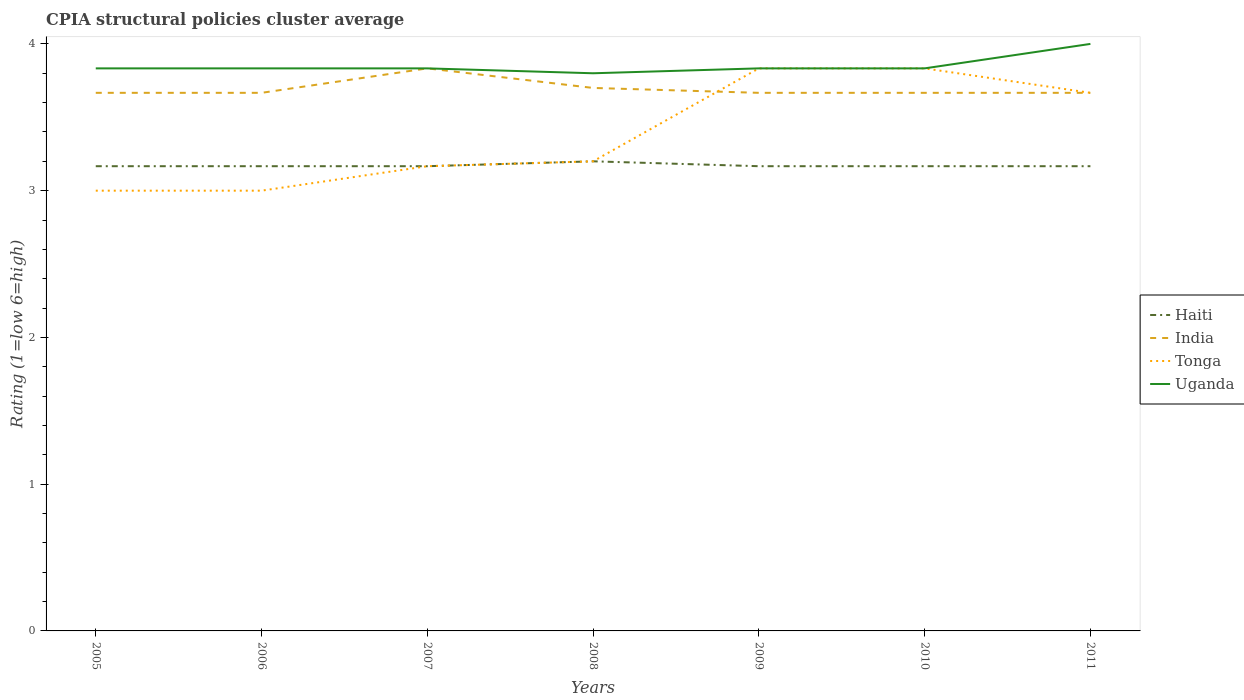Does the line corresponding to India intersect with the line corresponding to Uganda?
Your answer should be compact. Yes. What is the total CPIA rating in India in the graph?
Provide a short and direct response. 0.03. What is the difference between the highest and the second highest CPIA rating in India?
Your response must be concise. 0.17. What is the difference between the highest and the lowest CPIA rating in Haiti?
Your answer should be very brief. 1. Is the CPIA rating in Uganda strictly greater than the CPIA rating in India over the years?
Keep it short and to the point. No. What is the difference between two consecutive major ticks on the Y-axis?
Offer a terse response. 1. Where does the legend appear in the graph?
Make the answer very short. Center right. How many legend labels are there?
Offer a terse response. 4. How are the legend labels stacked?
Provide a succinct answer. Vertical. What is the title of the graph?
Make the answer very short. CPIA structural policies cluster average. Does "Russian Federation" appear as one of the legend labels in the graph?
Provide a succinct answer. No. What is the label or title of the X-axis?
Offer a very short reply. Years. What is the Rating (1=low 6=high) in Haiti in 2005?
Your answer should be compact. 3.17. What is the Rating (1=low 6=high) of India in 2005?
Your answer should be very brief. 3.67. What is the Rating (1=low 6=high) of Uganda in 2005?
Your answer should be very brief. 3.83. What is the Rating (1=low 6=high) of Haiti in 2006?
Give a very brief answer. 3.17. What is the Rating (1=low 6=high) of India in 2006?
Offer a very short reply. 3.67. What is the Rating (1=low 6=high) of Uganda in 2006?
Ensure brevity in your answer.  3.83. What is the Rating (1=low 6=high) in Haiti in 2007?
Provide a succinct answer. 3.17. What is the Rating (1=low 6=high) in India in 2007?
Offer a very short reply. 3.83. What is the Rating (1=low 6=high) of Tonga in 2007?
Make the answer very short. 3.17. What is the Rating (1=low 6=high) of Uganda in 2007?
Your answer should be compact. 3.83. What is the Rating (1=low 6=high) in Haiti in 2008?
Offer a terse response. 3.2. What is the Rating (1=low 6=high) of Tonga in 2008?
Offer a very short reply. 3.2. What is the Rating (1=low 6=high) in Haiti in 2009?
Your response must be concise. 3.17. What is the Rating (1=low 6=high) of India in 2009?
Your answer should be compact. 3.67. What is the Rating (1=low 6=high) in Tonga in 2009?
Ensure brevity in your answer.  3.83. What is the Rating (1=low 6=high) of Uganda in 2009?
Your answer should be very brief. 3.83. What is the Rating (1=low 6=high) of Haiti in 2010?
Offer a terse response. 3.17. What is the Rating (1=low 6=high) of India in 2010?
Your answer should be very brief. 3.67. What is the Rating (1=low 6=high) of Tonga in 2010?
Your response must be concise. 3.83. What is the Rating (1=low 6=high) in Uganda in 2010?
Provide a succinct answer. 3.83. What is the Rating (1=low 6=high) of Haiti in 2011?
Your answer should be compact. 3.17. What is the Rating (1=low 6=high) of India in 2011?
Give a very brief answer. 3.67. What is the Rating (1=low 6=high) of Tonga in 2011?
Offer a very short reply. 3.67. Across all years, what is the maximum Rating (1=low 6=high) in Haiti?
Keep it short and to the point. 3.2. Across all years, what is the maximum Rating (1=low 6=high) of India?
Offer a very short reply. 3.83. Across all years, what is the maximum Rating (1=low 6=high) in Tonga?
Provide a short and direct response. 3.83. Across all years, what is the minimum Rating (1=low 6=high) in Haiti?
Keep it short and to the point. 3.17. Across all years, what is the minimum Rating (1=low 6=high) in India?
Provide a succinct answer. 3.67. Across all years, what is the minimum Rating (1=low 6=high) of Tonga?
Your answer should be very brief. 3. Across all years, what is the minimum Rating (1=low 6=high) of Uganda?
Make the answer very short. 3.8. What is the total Rating (1=low 6=high) of Haiti in the graph?
Give a very brief answer. 22.2. What is the total Rating (1=low 6=high) of India in the graph?
Offer a very short reply. 25.87. What is the total Rating (1=low 6=high) of Tonga in the graph?
Give a very brief answer. 23.7. What is the total Rating (1=low 6=high) of Uganda in the graph?
Your answer should be very brief. 26.97. What is the difference between the Rating (1=low 6=high) in Haiti in 2005 and that in 2006?
Keep it short and to the point. 0. What is the difference between the Rating (1=low 6=high) in India in 2005 and that in 2006?
Keep it short and to the point. 0. What is the difference between the Rating (1=low 6=high) in Tonga in 2005 and that in 2006?
Your answer should be compact. 0. What is the difference between the Rating (1=low 6=high) in India in 2005 and that in 2007?
Ensure brevity in your answer.  -0.17. What is the difference between the Rating (1=low 6=high) of Haiti in 2005 and that in 2008?
Give a very brief answer. -0.03. What is the difference between the Rating (1=low 6=high) of India in 2005 and that in 2008?
Provide a succinct answer. -0.03. What is the difference between the Rating (1=low 6=high) of Uganda in 2005 and that in 2008?
Ensure brevity in your answer.  0.03. What is the difference between the Rating (1=low 6=high) of India in 2005 and that in 2009?
Provide a succinct answer. 0. What is the difference between the Rating (1=low 6=high) of Uganda in 2005 and that in 2009?
Offer a very short reply. 0. What is the difference between the Rating (1=low 6=high) in India in 2005 and that in 2010?
Keep it short and to the point. 0. What is the difference between the Rating (1=low 6=high) of Tonga in 2005 and that in 2010?
Your response must be concise. -0.83. What is the difference between the Rating (1=low 6=high) of Haiti in 2005 and that in 2011?
Your response must be concise. 0. What is the difference between the Rating (1=low 6=high) of India in 2005 and that in 2011?
Your answer should be very brief. 0. What is the difference between the Rating (1=low 6=high) in Uganda in 2005 and that in 2011?
Keep it short and to the point. -0.17. What is the difference between the Rating (1=low 6=high) of India in 2006 and that in 2007?
Offer a terse response. -0.17. What is the difference between the Rating (1=low 6=high) of Tonga in 2006 and that in 2007?
Ensure brevity in your answer.  -0.17. What is the difference between the Rating (1=low 6=high) of Haiti in 2006 and that in 2008?
Make the answer very short. -0.03. What is the difference between the Rating (1=low 6=high) of India in 2006 and that in 2008?
Ensure brevity in your answer.  -0.03. What is the difference between the Rating (1=low 6=high) in Tonga in 2006 and that in 2008?
Give a very brief answer. -0.2. What is the difference between the Rating (1=low 6=high) of Uganda in 2006 and that in 2008?
Provide a succinct answer. 0.03. What is the difference between the Rating (1=low 6=high) of Haiti in 2006 and that in 2009?
Offer a very short reply. 0. What is the difference between the Rating (1=low 6=high) in Tonga in 2006 and that in 2009?
Provide a short and direct response. -0.83. What is the difference between the Rating (1=low 6=high) in Tonga in 2006 and that in 2010?
Provide a succinct answer. -0.83. What is the difference between the Rating (1=low 6=high) in Uganda in 2006 and that in 2010?
Make the answer very short. 0. What is the difference between the Rating (1=low 6=high) of Haiti in 2006 and that in 2011?
Your answer should be compact. 0. What is the difference between the Rating (1=low 6=high) of India in 2006 and that in 2011?
Your answer should be compact. 0. What is the difference between the Rating (1=low 6=high) of Tonga in 2006 and that in 2011?
Make the answer very short. -0.67. What is the difference between the Rating (1=low 6=high) of Haiti in 2007 and that in 2008?
Provide a short and direct response. -0.03. What is the difference between the Rating (1=low 6=high) of India in 2007 and that in 2008?
Provide a short and direct response. 0.13. What is the difference between the Rating (1=low 6=high) of Tonga in 2007 and that in 2008?
Your answer should be compact. -0.03. What is the difference between the Rating (1=low 6=high) of Haiti in 2007 and that in 2009?
Your answer should be compact. 0. What is the difference between the Rating (1=low 6=high) in Tonga in 2007 and that in 2010?
Provide a short and direct response. -0.67. What is the difference between the Rating (1=low 6=high) of Uganda in 2007 and that in 2010?
Provide a short and direct response. 0. What is the difference between the Rating (1=low 6=high) in Haiti in 2007 and that in 2011?
Offer a very short reply. 0. What is the difference between the Rating (1=low 6=high) in India in 2007 and that in 2011?
Offer a terse response. 0.17. What is the difference between the Rating (1=low 6=high) in Tonga in 2007 and that in 2011?
Provide a succinct answer. -0.5. What is the difference between the Rating (1=low 6=high) of Uganda in 2007 and that in 2011?
Provide a short and direct response. -0.17. What is the difference between the Rating (1=low 6=high) of Haiti in 2008 and that in 2009?
Make the answer very short. 0.03. What is the difference between the Rating (1=low 6=high) in Tonga in 2008 and that in 2009?
Offer a terse response. -0.63. What is the difference between the Rating (1=low 6=high) of Uganda in 2008 and that in 2009?
Make the answer very short. -0.03. What is the difference between the Rating (1=low 6=high) in Haiti in 2008 and that in 2010?
Your answer should be compact. 0.03. What is the difference between the Rating (1=low 6=high) of India in 2008 and that in 2010?
Your response must be concise. 0.03. What is the difference between the Rating (1=low 6=high) in Tonga in 2008 and that in 2010?
Keep it short and to the point. -0.63. What is the difference between the Rating (1=low 6=high) in Uganda in 2008 and that in 2010?
Make the answer very short. -0.03. What is the difference between the Rating (1=low 6=high) in Haiti in 2008 and that in 2011?
Provide a short and direct response. 0.03. What is the difference between the Rating (1=low 6=high) in Tonga in 2008 and that in 2011?
Keep it short and to the point. -0.47. What is the difference between the Rating (1=low 6=high) of Tonga in 2009 and that in 2010?
Offer a very short reply. 0. What is the difference between the Rating (1=low 6=high) in India in 2009 and that in 2011?
Ensure brevity in your answer.  0. What is the difference between the Rating (1=low 6=high) of Tonga in 2009 and that in 2011?
Provide a short and direct response. 0.17. What is the difference between the Rating (1=low 6=high) in Haiti in 2010 and that in 2011?
Provide a short and direct response. 0. What is the difference between the Rating (1=low 6=high) of Uganda in 2010 and that in 2011?
Keep it short and to the point. -0.17. What is the difference between the Rating (1=low 6=high) in Haiti in 2005 and the Rating (1=low 6=high) in Tonga in 2006?
Offer a very short reply. 0.17. What is the difference between the Rating (1=low 6=high) of Haiti in 2005 and the Rating (1=low 6=high) of Uganda in 2006?
Make the answer very short. -0.67. What is the difference between the Rating (1=low 6=high) in Haiti in 2005 and the Rating (1=low 6=high) in India in 2007?
Your answer should be compact. -0.67. What is the difference between the Rating (1=low 6=high) of Haiti in 2005 and the Rating (1=low 6=high) of Tonga in 2007?
Give a very brief answer. 0. What is the difference between the Rating (1=low 6=high) of Haiti in 2005 and the Rating (1=low 6=high) of Uganda in 2007?
Your answer should be very brief. -0.67. What is the difference between the Rating (1=low 6=high) in India in 2005 and the Rating (1=low 6=high) in Uganda in 2007?
Offer a terse response. -0.17. What is the difference between the Rating (1=low 6=high) in Haiti in 2005 and the Rating (1=low 6=high) in India in 2008?
Offer a very short reply. -0.53. What is the difference between the Rating (1=low 6=high) of Haiti in 2005 and the Rating (1=low 6=high) of Tonga in 2008?
Ensure brevity in your answer.  -0.03. What is the difference between the Rating (1=low 6=high) of Haiti in 2005 and the Rating (1=low 6=high) of Uganda in 2008?
Keep it short and to the point. -0.63. What is the difference between the Rating (1=low 6=high) of India in 2005 and the Rating (1=low 6=high) of Tonga in 2008?
Provide a short and direct response. 0.47. What is the difference between the Rating (1=low 6=high) in India in 2005 and the Rating (1=low 6=high) in Uganda in 2008?
Your answer should be compact. -0.13. What is the difference between the Rating (1=low 6=high) of Tonga in 2005 and the Rating (1=low 6=high) of Uganda in 2008?
Provide a short and direct response. -0.8. What is the difference between the Rating (1=low 6=high) in Haiti in 2005 and the Rating (1=low 6=high) in India in 2009?
Offer a very short reply. -0.5. What is the difference between the Rating (1=low 6=high) of Haiti in 2005 and the Rating (1=low 6=high) of Tonga in 2009?
Offer a terse response. -0.67. What is the difference between the Rating (1=low 6=high) in India in 2005 and the Rating (1=low 6=high) in Uganda in 2009?
Give a very brief answer. -0.17. What is the difference between the Rating (1=low 6=high) of Tonga in 2005 and the Rating (1=low 6=high) of Uganda in 2009?
Your response must be concise. -0.83. What is the difference between the Rating (1=low 6=high) of Haiti in 2005 and the Rating (1=low 6=high) of Uganda in 2010?
Keep it short and to the point. -0.67. What is the difference between the Rating (1=low 6=high) in India in 2005 and the Rating (1=low 6=high) in Tonga in 2010?
Offer a very short reply. -0.17. What is the difference between the Rating (1=low 6=high) in India in 2005 and the Rating (1=low 6=high) in Uganda in 2010?
Keep it short and to the point. -0.17. What is the difference between the Rating (1=low 6=high) in Haiti in 2005 and the Rating (1=low 6=high) in India in 2011?
Offer a terse response. -0.5. What is the difference between the Rating (1=low 6=high) of Haiti in 2005 and the Rating (1=low 6=high) of Tonga in 2011?
Offer a very short reply. -0.5. What is the difference between the Rating (1=low 6=high) of Haiti in 2005 and the Rating (1=low 6=high) of Uganda in 2011?
Your response must be concise. -0.83. What is the difference between the Rating (1=low 6=high) of India in 2005 and the Rating (1=low 6=high) of Uganda in 2011?
Give a very brief answer. -0.33. What is the difference between the Rating (1=low 6=high) of Haiti in 2006 and the Rating (1=low 6=high) of Tonga in 2007?
Your answer should be compact. 0. What is the difference between the Rating (1=low 6=high) of Haiti in 2006 and the Rating (1=low 6=high) of Uganda in 2007?
Your answer should be very brief. -0.67. What is the difference between the Rating (1=low 6=high) in Tonga in 2006 and the Rating (1=low 6=high) in Uganda in 2007?
Keep it short and to the point. -0.83. What is the difference between the Rating (1=low 6=high) of Haiti in 2006 and the Rating (1=low 6=high) of India in 2008?
Make the answer very short. -0.53. What is the difference between the Rating (1=low 6=high) in Haiti in 2006 and the Rating (1=low 6=high) in Tonga in 2008?
Make the answer very short. -0.03. What is the difference between the Rating (1=low 6=high) of Haiti in 2006 and the Rating (1=low 6=high) of Uganda in 2008?
Keep it short and to the point. -0.63. What is the difference between the Rating (1=low 6=high) in India in 2006 and the Rating (1=low 6=high) in Tonga in 2008?
Provide a short and direct response. 0.47. What is the difference between the Rating (1=low 6=high) of India in 2006 and the Rating (1=low 6=high) of Uganda in 2008?
Provide a succinct answer. -0.13. What is the difference between the Rating (1=low 6=high) in Tonga in 2006 and the Rating (1=low 6=high) in Uganda in 2008?
Your answer should be very brief. -0.8. What is the difference between the Rating (1=low 6=high) of Haiti in 2006 and the Rating (1=low 6=high) of Uganda in 2009?
Your answer should be very brief. -0.67. What is the difference between the Rating (1=low 6=high) of India in 2006 and the Rating (1=low 6=high) of Tonga in 2009?
Your answer should be very brief. -0.17. What is the difference between the Rating (1=low 6=high) of India in 2006 and the Rating (1=low 6=high) of Uganda in 2009?
Keep it short and to the point. -0.17. What is the difference between the Rating (1=low 6=high) in Haiti in 2006 and the Rating (1=low 6=high) in Tonga in 2010?
Provide a short and direct response. -0.67. What is the difference between the Rating (1=low 6=high) in India in 2006 and the Rating (1=low 6=high) in Tonga in 2010?
Provide a short and direct response. -0.17. What is the difference between the Rating (1=low 6=high) of Tonga in 2006 and the Rating (1=low 6=high) of Uganda in 2010?
Your answer should be very brief. -0.83. What is the difference between the Rating (1=low 6=high) of Tonga in 2006 and the Rating (1=low 6=high) of Uganda in 2011?
Offer a terse response. -1. What is the difference between the Rating (1=low 6=high) in Haiti in 2007 and the Rating (1=low 6=high) in India in 2008?
Offer a very short reply. -0.53. What is the difference between the Rating (1=low 6=high) of Haiti in 2007 and the Rating (1=low 6=high) of Tonga in 2008?
Offer a very short reply. -0.03. What is the difference between the Rating (1=low 6=high) of Haiti in 2007 and the Rating (1=low 6=high) of Uganda in 2008?
Provide a short and direct response. -0.63. What is the difference between the Rating (1=low 6=high) in India in 2007 and the Rating (1=low 6=high) in Tonga in 2008?
Keep it short and to the point. 0.63. What is the difference between the Rating (1=low 6=high) of India in 2007 and the Rating (1=low 6=high) of Uganda in 2008?
Offer a very short reply. 0.03. What is the difference between the Rating (1=low 6=high) of Tonga in 2007 and the Rating (1=low 6=high) of Uganda in 2008?
Your answer should be very brief. -0.63. What is the difference between the Rating (1=low 6=high) in Haiti in 2007 and the Rating (1=low 6=high) in India in 2009?
Ensure brevity in your answer.  -0.5. What is the difference between the Rating (1=low 6=high) of Haiti in 2007 and the Rating (1=low 6=high) of Uganda in 2009?
Your response must be concise. -0.67. What is the difference between the Rating (1=low 6=high) of Tonga in 2007 and the Rating (1=low 6=high) of Uganda in 2009?
Provide a short and direct response. -0.67. What is the difference between the Rating (1=low 6=high) of India in 2007 and the Rating (1=low 6=high) of Tonga in 2010?
Your response must be concise. 0. What is the difference between the Rating (1=low 6=high) of Haiti in 2007 and the Rating (1=low 6=high) of India in 2011?
Offer a very short reply. -0.5. What is the difference between the Rating (1=low 6=high) of India in 2007 and the Rating (1=low 6=high) of Tonga in 2011?
Your answer should be very brief. 0.17. What is the difference between the Rating (1=low 6=high) of India in 2007 and the Rating (1=low 6=high) of Uganda in 2011?
Provide a short and direct response. -0.17. What is the difference between the Rating (1=low 6=high) of Haiti in 2008 and the Rating (1=low 6=high) of India in 2009?
Keep it short and to the point. -0.47. What is the difference between the Rating (1=low 6=high) in Haiti in 2008 and the Rating (1=low 6=high) in Tonga in 2009?
Offer a very short reply. -0.63. What is the difference between the Rating (1=low 6=high) of Haiti in 2008 and the Rating (1=low 6=high) of Uganda in 2009?
Give a very brief answer. -0.63. What is the difference between the Rating (1=low 6=high) in India in 2008 and the Rating (1=low 6=high) in Tonga in 2009?
Provide a succinct answer. -0.13. What is the difference between the Rating (1=low 6=high) in India in 2008 and the Rating (1=low 6=high) in Uganda in 2009?
Ensure brevity in your answer.  -0.13. What is the difference between the Rating (1=low 6=high) of Tonga in 2008 and the Rating (1=low 6=high) of Uganda in 2009?
Your answer should be compact. -0.63. What is the difference between the Rating (1=low 6=high) in Haiti in 2008 and the Rating (1=low 6=high) in India in 2010?
Keep it short and to the point. -0.47. What is the difference between the Rating (1=low 6=high) of Haiti in 2008 and the Rating (1=low 6=high) of Tonga in 2010?
Your response must be concise. -0.63. What is the difference between the Rating (1=low 6=high) of Haiti in 2008 and the Rating (1=low 6=high) of Uganda in 2010?
Give a very brief answer. -0.63. What is the difference between the Rating (1=low 6=high) of India in 2008 and the Rating (1=low 6=high) of Tonga in 2010?
Provide a short and direct response. -0.13. What is the difference between the Rating (1=low 6=high) in India in 2008 and the Rating (1=low 6=high) in Uganda in 2010?
Keep it short and to the point. -0.13. What is the difference between the Rating (1=low 6=high) in Tonga in 2008 and the Rating (1=low 6=high) in Uganda in 2010?
Give a very brief answer. -0.63. What is the difference between the Rating (1=low 6=high) in Haiti in 2008 and the Rating (1=low 6=high) in India in 2011?
Your answer should be compact. -0.47. What is the difference between the Rating (1=low 6=high) in Haiti in 2008 and the Rating (1=low 6=high) in Tonga in 2011?
Ensure brevity in your answer.  -0.47. What is the difference between the Rating (1=low 6=high) of Haiti in 2008 and the Rating (1=low 6=high) of Uganda in 2011?
Provide a short and direct response. -0.8. What is the difference between the Rating (1=low 6=high) in Haiti in 2009 and the Rating (1=low 6=high) in Uganda in 2010?
Make the answer very short. -0.67. What is the difference between the Rating (1=low 6=high) of India in 2009 and the Rating (1=low 6=high) of Uganda in 2010?
Ensure brevity in your answer.  -0.17. What is the difference between the Rating (1=low 6=high) in Haiti in 2009 and the Rating (1=low 6=high) in Tonga in 2011?
Give a very brief answer. -0.5. What is the difference between the Rating (1=low 6=high) of Haiti in 2009 and the Rating (1=low 6=high) of Uganda in 2011?
Offer a terse response. -0.83. What is the difference between the Rating (1=low 6=high) of Tonga in 2009 and the Rating (1=low 6=high) of Uganda in 2011?
Give a very brief answer. -0.17. What is the difference between the Rating (1=low 6=high) of Haiti in 2010 and the Rating (1=low 6=high) of India in 2011?
Keep it short and to the point. -0.5. What is the difference between the Rating (1=low 6=high) in Haiti in 2010 and the Rating (1=low 6=high) in Uganda in 2011?
Provide a short and direct response. -0.83. What is the average Rating (1=low 6=high) in Haiti per year?
Keep it short and to the point. 3.17. What is the average Rating (1=low 6=high) in India per year?
Offer a very short reply. 3.7. What is the average Rating (1=low 6=high) in Tonga per year?
Ensure brevity in your answer.  3.39. What is the average Rating (1=low 6=high) in Uganda per year?
Provide a succinct answer. 3.85. In the year 2005, what is the difference between the Rating (1=low 6=high) in Haiti and Rating (1=low 6=high) in Tonga?
Offer a very short reply. 0.17. In the year 2005, what is the difference between the Rating (1=low 6=high) of Haiti and Rating (1=low 6=high) of Uganda?
Your answer should be compact. -0.67. In the year 2005, what is the difference between the Rating (1=low 6=high) in India and Rating (1=low 6=high) in Tonga?
Keep it short and to the point. 0.67. In the year 2005, what is the difference between the Rating (1=low 6=high) in Tonga and Rating (1=low 6=high) in Uganda?
Make the answer very short. -0.83. In the year 2006, what is the difference between the Rating (1=low 6=high) in Haiti and Rating (1=low 6=high) in Tonga?
Provide a succinct answer. 0.17. In the year 2006, what is the difference between the Rating (1=low 6=high) in Haiti and Rating (1=low 6=high) in Uganda?
Your response must be concise. -0.67. In the year 2006, what is the difference between the Rating (1=low 6=high) in India and Rating (1=low 6=high) in Tonga?
Provide a succinct answer. 0.67. In the year 2007, what is the difference between the Rating (1=low 6=high) in Haiti and Rating (1=low 6=high) in Uganda?
Provide a short and direct response. -0.67. In the year 2007, what is the difference between the Rating (1=low 6=high) of Tonga and Rating (1=low 6=high) of Uganda?
Offer a very short reply. -0.67. In the year 2008, what is the difference between the Rating (1=low 6=high) in Haiti and Rating (1=low 6=high) in Tonga?
Keep it short and to the point. 0. In the year 2008, what is the difference between the Rating (1=low 6=high) in Haiti and Rating (1=low 6=high) in Uganda?
Your response must be concise. -0.6. In the year 2008, what is the difference between the Rating (1=low 6=high) in Tonga and Rating (1=low 6=high) in Uganda?
Ensure brevity in your answer.  -0.6. In the year 2009, what is the difference between the Rating (1=low 6=high) of Haiti and Rating (1=low 6=high) of Uganda?
Provide a succinct answer. -0.67. In the year 2009, what is the difference between the Rating (1=low 6=high) in Tonga and Rating (1=low 6=high) in Uganda?
Keep it short and to the point. 0. In the year 2010, what is the difference between the Rating (1=low 6=high) in India and Rating (1=low 6=high) in Uganda?
Offer a terse response. -0.17. In the year 2011, what is the difference between the Rating (1=low 6=high) in Haiti and Rating (1=low 6=high) in Tonga?
Your response must be concise. -0.5. In the year 2011, what is the difference between the Rating (1=low 6=high) of India and Rating (1=low 6=high) of Uganda?
Give a very brief answer. -0.33. In the year 2011, what is the difference between the Rating (1=low 6=high) of Tonga and Rating (1=low 6=high) of Uganda?
Ensure brevity in your answer.  -0.33. What is the ratio of the Rating (1=low 6=high) of India in 2005 to that in 2006?
Offer a terse response. 1. What is the ratio of the Rating (1=low 6=high) of Tonga in 2005 to that in 2006?
Your answer should be compact. 1. What is the ratio of the Rating (1=low 6=high) in Haiti in 2005 to that in 2007?
Your response must be concise. 1. What is the ratio of the Rating (1=low 6=high) in India in 2005 to that in 2007?
Keep it short and to the point. 0.96. What is the ratio of the Rating (1=low 6=high) in Tonga in 2005 to that in 2007?
Keep it short and to the point. 0.95. What is the ratio of the Rating (1=low 6=high) in Uganda in 2005 to that in 2007?
Offer a very short reply. 1. What is the ratio of the Rating (1=low 6=high) in Haiti in 2005 to that in 2008?
Give a very brief answer. 0.99. What is the ratio of the Rating (1=low 6=high) of India in 2005 to that in 2008?
Your answer should be compact. 0.99. What is the ratio of the Rating (1=low 6=high) in Tonga in 2005 to that in 2008?
Ensure brevity in your answer.  0.94. What is the ratio of the Rating (1=low 6=high) of Uganda in 2005 to that in 2008?
Your answer should be very brief. 1.01. What is the ratio of the Rating (1=low 6=high) in Tonga in 2005 to that in 2009?
Give a very brief answer. 0.78. What is the ratio of the Rating (1=low 6=high) of Haiti in 2005 to that in 2010?
Offer a very short reply. 1. What is the ratio of the Rating (1=low 6=high) in Tonga in 2005 to that in 2010?
Offer a very short reply. 0.78. What is the ratio of the Rating (1=low 6=high) in Uganda in 2005 to that in 2010?
Provide a succinct answer. 1. What is the ratio of the Rating (1=low 6=high) in India in 2005 to that in 2011?
Provide a succinct answer. 1. What is the ratio of the Rating (1=low 6=high) of Tonga in 2005 to that in 2011?
Provide a succinct answer. 0.82. What is the ratio of the Rating (1=low 6=high) in Uganda in 2005 to that in 2011?
Ensure brevity in your answer.  0.96. What is the ratio of the Rating (1=low 6=high) in India in 2006 to that in 2007?
Provide a succinct answer. 0.96. What is the ratio of the Rating (1=low 6=high) in Uganda in 2006 to that in 2007?
Provide a short and direct response. 1. What is the ratio of the Rating (1=low 6=high) in Uganda in 2006 to that in 2008?
Give a very brief answer. 1.01. What is the ratio of the Rating (1=low 6=high) in Haiti in 2006 to that in 2009?
Provide a succinct answer. 1. What is the ratio of the Rating (1=low 6=high) in Tonga in 2006 to that in 2009?
Give a very brief answer. 0.78. What is the ratio of the Rating (1=low 6=high) in Uganda in 2006 to that in 2009?
Ensure brevity in your answer.  1. What is the ratio of the Rating (1=low 6=high) in Haiti in 2006 to that in 2010?
Offer a terse response. 1. What is the ratio of the Rating (1=low 6=high) of Tonga in 2006 to that in 2010?
Your response must be concise. 0.78. What is the ratio of the Rating (1=low 6=high) in Uganda in 2006 to that in 2010?
Give a very brief answer. 1. What is the ratio of the Rating (1=low 6=high) in Haiti in 2006 to that in 2011?
Your answer should be very brief. 1. What is the ratio of the Rating (1=low 6=high) of Tonga in 2006 to that in 2011?
Your answer should be compact. 0.82. What is the ratio of the Rating (1=low 6=high) in India in 2007 to that in 2008?
Make the answer very short. 1.04. What is the ratio of the Rating (1=low 6=high) in Tonga in 2007 to that in 2008?
Your response must be concise. 0.99. What is the ratio of the Rating (1=low 6=high) of Uganda in 2007 to that in 2008?
Your answer should be very brief. 1.01. What is the ratio of the Rating (1=low 6=high) in India in 2007 to that in 2009?
Provide a short and direct response. 1.05. What is the ratio of the Rating (1=low 6=high) of Tonga in 2007 to that in 2009?
Ensure brevity in your answer.  0.83. What is the ratio of the Rating (1=low 6=high) of Haiti in 2007 to that in 2010?
Provide a short and direct response. 1. What is the ratio of the Rating (1=low 6=high) in India in 2007 to that in 2010?
Your answer should be very brief. 1.05. What is the ratio of the Rating (1=low 6=high) of Tonga in 2007 to that in 2010?
Your answer should be compact. 0.83. What is the ratio of the Rating (1=low 6=high) in Haiti in 2007 to that in 2011?
Keep it short and to the point. 1. What is the ratio of the Rating (1=low 6=high) of India in 2007 to that in 2011?
Make the answer very short. 1.05. What is the ratio of the Rating (1=low 6=high) in Tonga in 2007 to that in 2011?
Provide a succinct answer. 0.86. What is the ratio of the Rating (1=low 6=high) in Uganda in 2007 to that in 2011?
Offer a terse response. 0.96. What is the ratio of the Rating (1=low 6=high) in Haiti in 2008 to that in 2009?
Ensure brevity in your answer.  1.01. What is the ratio of the Rating (1=low 6=high) of India in 2008 to that in 2009?
Make the answer very short. 1.01. What is the ratio of the Rating (1=low 6=high) of Tonga in 2008 to that in 2009?
Keep it short and to the point. 0.83. What is the ratio of the Rating (1=low 6=high) in Haiti in 2008 to that in 2010?
Your answer should be compact. 1.01. What is the ratio of the Rating (1=low 6=high) in India in 2008 to that in 2010?
Offer a very short reply. 1.01. What is the ratio of the Rating (1=low 6=high) in Tonga in 2008 to that in 2010?
Your response must be concise. 0.83. What is the ratio of the Rating (1=low 6=high) in Uganda in 2008 to that in 2010?
Provide a short and direct response. 0.99. What is the ratio of the Rating (1=low 6=high) in Haiti in 2008 to that in 2011?
Your answer should be very brief. 1.01. What is the ratio of the Rating (1=low 6=high) of India in 2008 to that in 2011?
Ensure brevity in your answer.  1.01. What is the ratio of the Rating (1=low 6=high) of Tonga in 2008 to that in 2011?
Ensure brevity in your answer.  0.87. What is the ratio of the Rating (1=low 6=high) in Haiti in 2009 to that in 2010?
Give a very brief answer. 1. What is the ratio of the Rating (1=low 6=high) of Uganda in 2009 to that in 2010?
Provide a short and direct response. 1. What is the ratio of the Rating (1=low 6=high) of Tonga in 2009 to that in 2011?
Keep it short and to the point. 1.05. What is the ratio of the Rating (1=low 6=high) of Uganda in 2009 to that in 2011?
Offer a terse response. 0.96. What is the ratio of the Rating (1=low 6=high) of Tonga in 2010 to that in 2011?
Give a very brief answer. 1.05. What is the ratio of the Rating (1=low 6=high) in Uganda in 2010 to that in 2011?
Provide a short and direct response. 0.96. What is the difference between the highest and the second highest Rating (1=low 6=high) of Haiti?
Offer a terse response. 0.03. What is the difference between the highest and the second highest Rating (1=low 6=high) of India?
Give a very brief answer. 0.13. What is the difference between the highest and the second highest Rating (1=low 6=high) of Tonga?
Your answer should be very brief. 0. What is the difference between the highest and the second highest Rating (1=low 6=high) in Uganda?
Provide a short and direct response. 0.17. What is the difference between the highest and the lowest Rating (1=low 6=high) of Haiti?
Your answer should be compact. 0.03. What is the difference between the highest and the lowest Rating (1=low 6=high) in Tonga?
Your answer should be very brief. 0.83. 